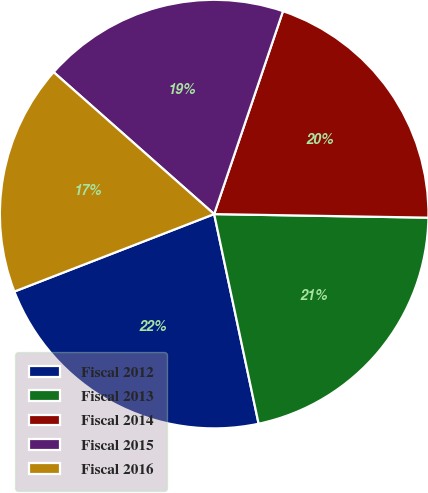Convert chart to OTSL. <chart><loc_0><loc_0><loc_500><loc_500><pie_chart><fcel>Fiscal 2012<fcel>Fiscal 2013<fcel>Fiscal 2014<fcel>Fiscal 2015<fcel>Fiscal 2016<nl><fcel>22.44%<fcel>21.41%<fcel>20.06%<fcel>18.68%<fcel>17.41%<nl></chart> 